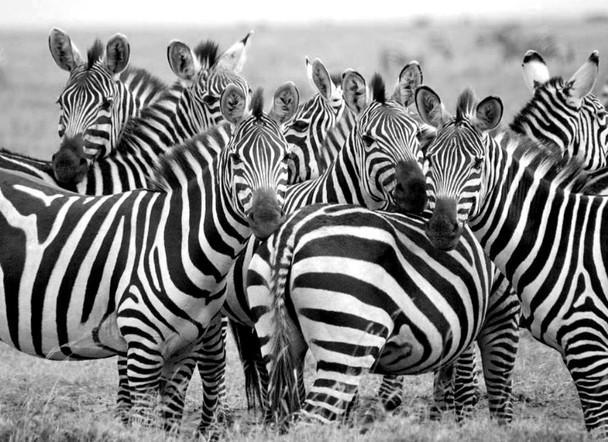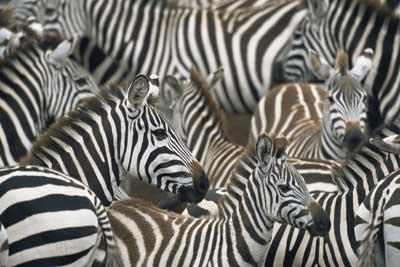The first image is the image on the left, the second image is the image on the right. Assess this claim about the two images: "In at least one image there are at least 8 zebra standing in tall grass.". Correct or not? Answer yes or no. Yes. The first image is the image on the left, the second image is the image on the right. Evaluate the accuracy of this statement regarding the images: "One image shows a mass of zebras with no visible space between or around them, and the other image shows a close grouping of zebras with space above them.". Is it true? Answer yes or no. Yes. 